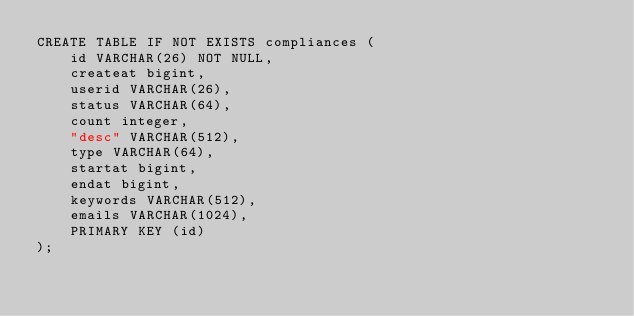Convert code to text. <code><loc_0><loc_0><loc_500><loc_500><_SQL_>CREATE TABLE IF NOT EXISTS compliances (
    id VARCHAR(26) NOT NULL,
    createat bigint,
    userid VARCHAR(26),
    status VARCHAR(64),
    count integer,
    "desc" VARCHAR(512),
    type VARCHAR(64),
    startat bigint,
    endat bigint,
    keywords VARCHAR(512),
    emails VARCHAR(1024),
    PRIMARY KEY (id)
);
</code> 